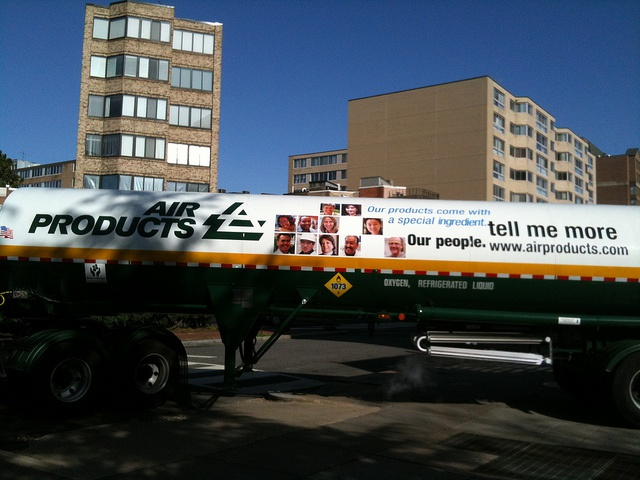Describe the objects in this image and their specific colors. I can see truck in blue, black, white, gray, and darkgray tones, people in blue, white, brown, maroon, and black tones, people in blue, maroon, black, and brown tones, people in blue, brown, lightpink, maroon, and darkgray tones, and people in blue, maroon, lightpink, black, and brown tones in this image. 